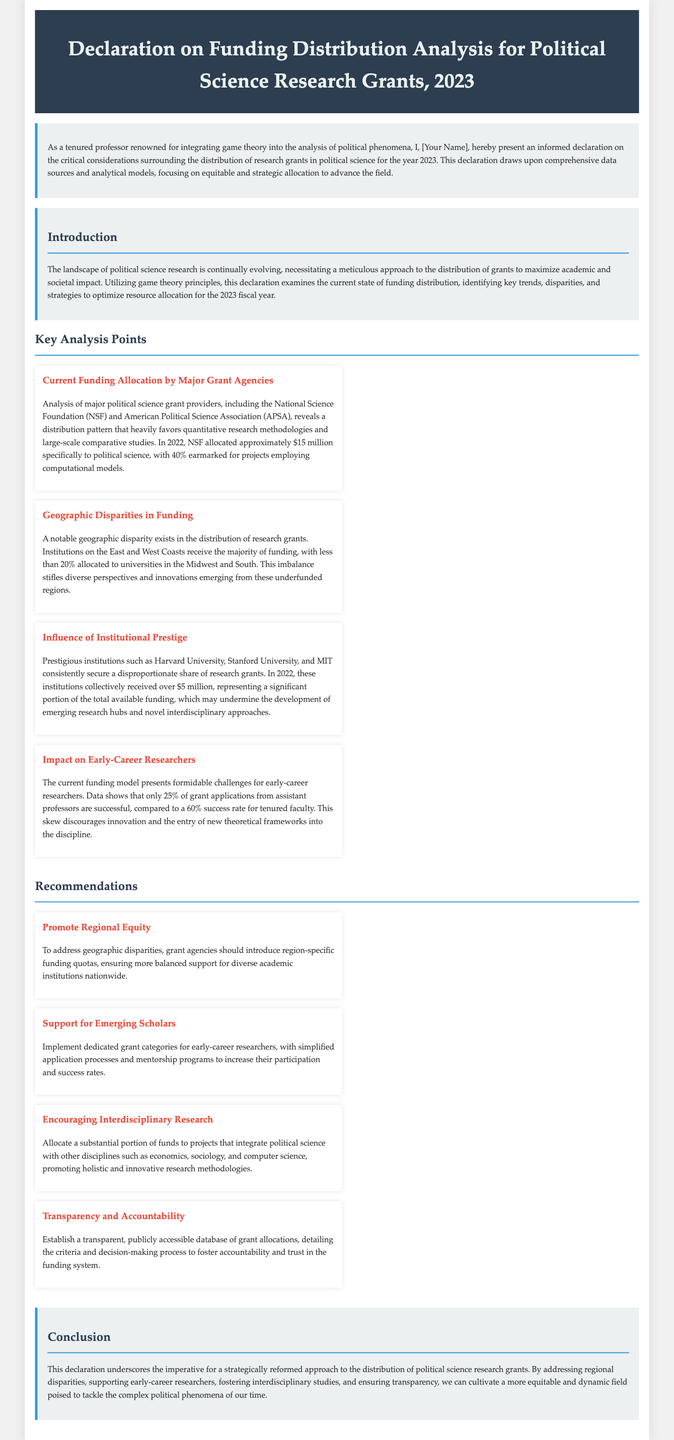what is the title of the declaration? The title of the declaration is found in the header section, stating the purpose of the document.
Answer: Declaration on Funding Distribution Analysis for Political Science Research Grants, 2023 who authored the declaration? The declaration mentions the author as a tenured professor known for integrating game theory into political analysis.
Answer: [Your Name] how much did NSF allocate to political science in 2022? The declaration provides a specific amount allocated by the NSF for political science research in 2022.
Answer: $15 million what percentage of NSF funding was earmarked for computational models? The document notes the specific percentage of allocated funds that was aimed at projects employing computational models.
Answer: 40% what is the success rate of assistant professors' grant applications? The document states the success rate of grant applications specifically for assistant professors in comparison to tenured faculty.
Answer: 25% which regions receive the majority of political science funding? The declaration highlights the geographic imbalance in funding distribution among various regions in the U.S.
Answer: East and West Coasts what is one recommendation for promoting regional equity? The declaration suggests a specific initiative aimed at rectifying geographic disparities in grant allocation.
Answer: region-specific funding quotas how much did prestigious institutions receive in 2022? The article mentions the total amount of funding awarded to certain prestigious institutions in a specific year.
Answer: over $5 million what is the overall aim of the recommendations in the declaration? The recommendations collectively intend to enhance specific aspects of the grant allocation system for better outcomes.
Answer: create a more equitable and dynamic field 